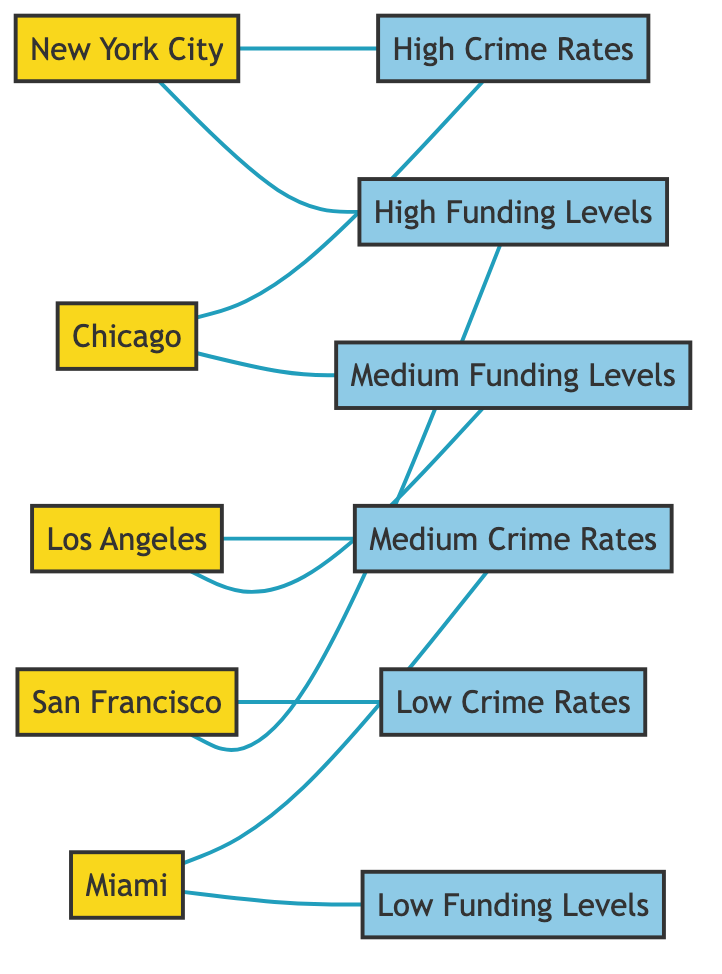What region is associated with High Crime Rates? The node "High Crime Rates" is connected to both "New York City" and "Chicago," indicating that these regions are associated with high crime rates.
Answer: New York City, Chicago How many regions are represented in the graph? By counting the nodes that are categorized as "Region," we find there are five regions: New York City, Los Angeles, Chicago, San Francisco, and Miami.
Answer: 5 Which region has Low Funding Levels? Reviewing the connections, "Miami" is linked to "Low Funding Levels," identifying it as the only region with this attribute.
Answer: Miami What type of crime rate is linked to San Francisco? The graph displays that "San Francisco" connects to "Low Crime Rates," indicating this is the type of crime rate associated with San Francisco.
Answer: Low Crime Rates Which regions are linked to Medium Crime Rates? By checking the connections, "Los Angeles" and "Miami" are both connected to "Medium Crime Rates," showing these regions correlate with this level of crime rate intensity.
Answer: Los Angeles, Miami How many connections does Chicago have? Chicago has two connections: one to "High Crime Rates" and another to "Medium Funding Levels." Therefore, it has a total of two edges connected to it.
Answer: 2 What is the relationship between High Funding Levels and San Francisco? The edge connects "San Francisco" to "High Funding Levels," showing that this region is associated with high funding levels.
Answer: High Funding Levels Which region has Medium Funding Levels? The search through the edges shows that "Los Angeles" is the only region directly connected to "Medium Funding Levels."
Answer: Los Angeles Are there any regions with High Crime Rates that have Medium Funding Levels? While two regions, New York City and Chicago, are linked to High Crime Rates, only Chicago is connected to Medium Funding Levels, thus establishing a direct link for just this region.
Answer: Chicago 